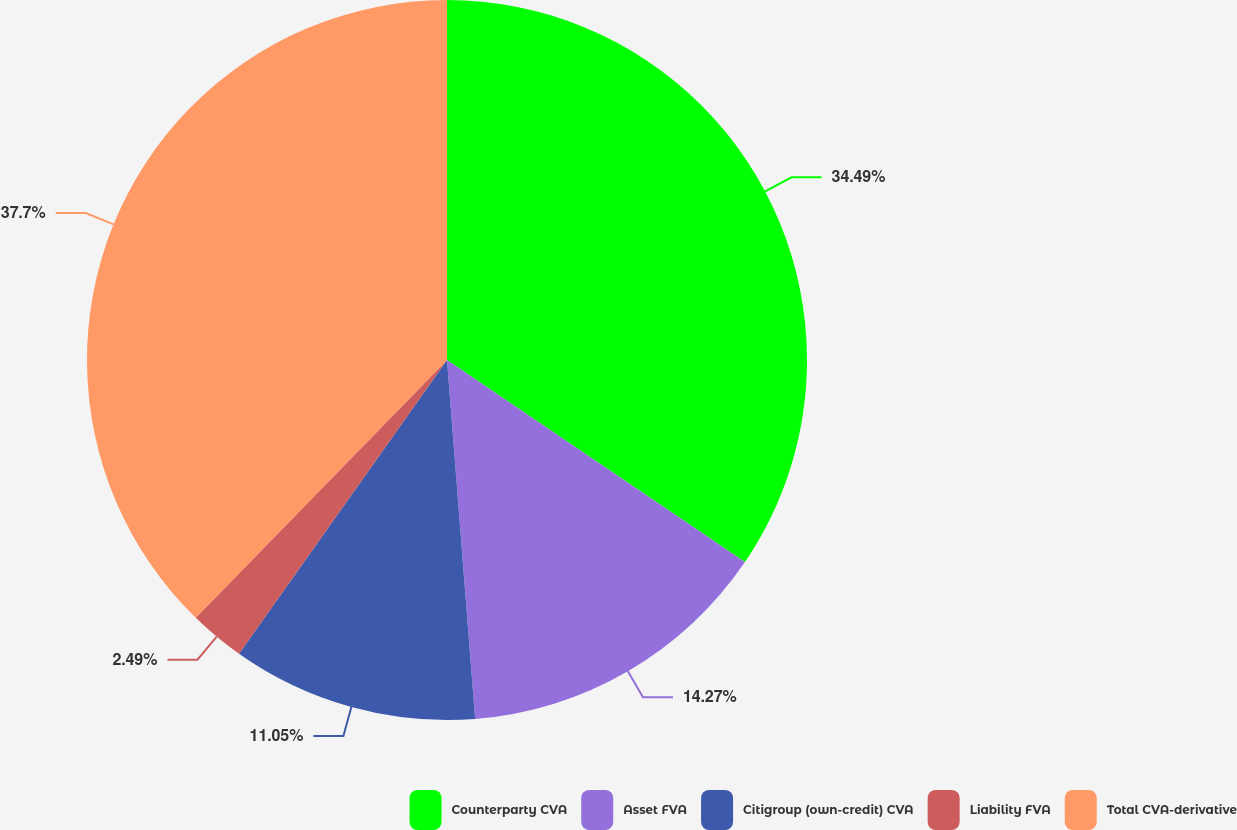Convert chart. <chart><loc_0><loc_0><loc_500><loc_500><pie_chart><fcel>Counterparty CVA<fcel>Asset FVA<fcel>Citigroup (own-credit) CVA<fcel>Liability FVA<fcel>Total CVA-derivative<nl><fcel>34.49%<fcel>14.27%<fcel>11.05%<fcel>2.49%<fcel>37.71%<nl></chart> 